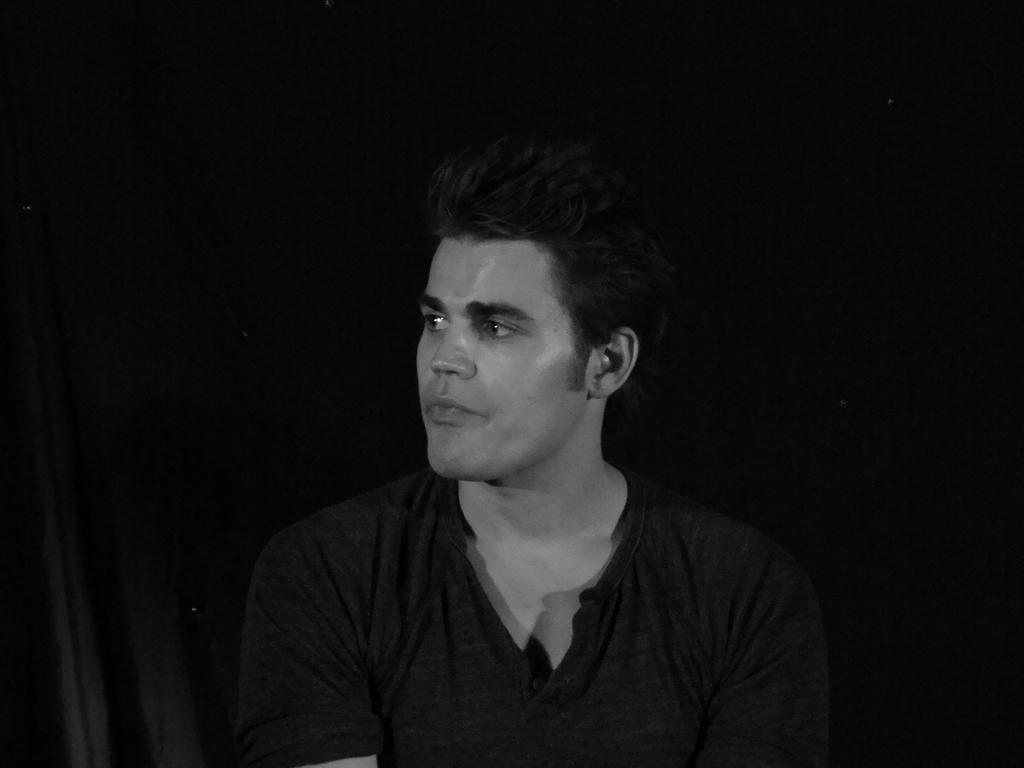What is the main subject of the image? There is a man in the image. What is the man wearing? The man is wearing a black T-shirt. Where is the man located in the image? The man is in the middle of the image. What type of door can be seen in the image? There is no door present in the image; it features a man wearing a black T-shirt. How many apples are visible in the image? There are no apples present in the image. 